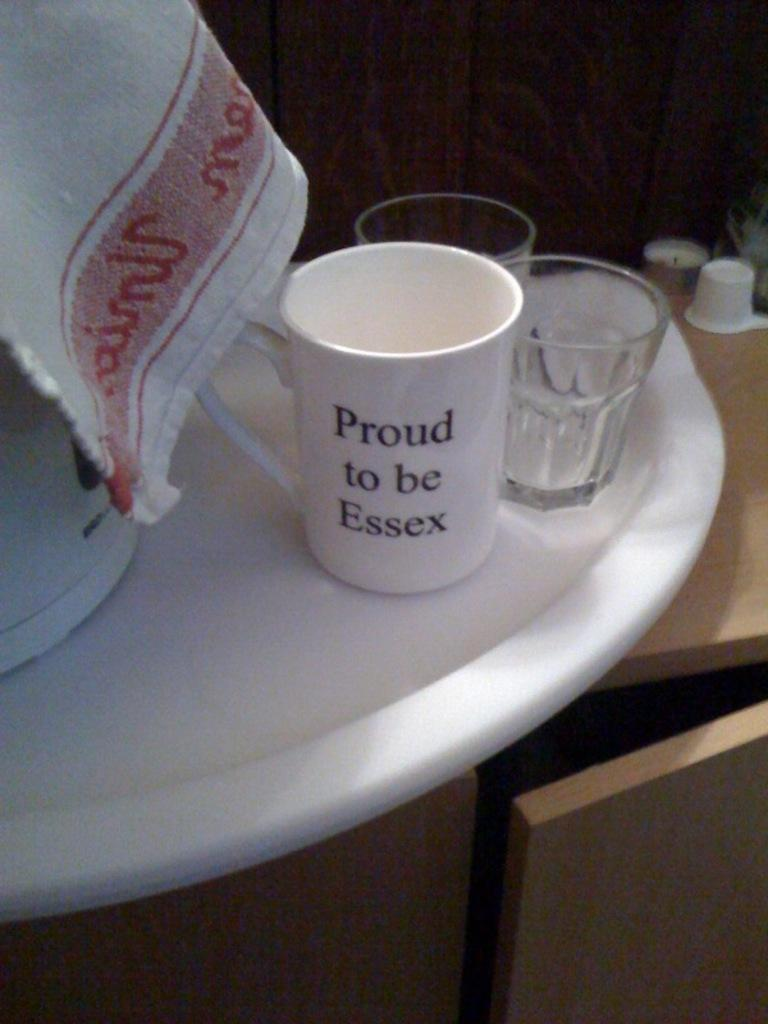What type of furniture is visible in the image? There is a wooden cupboard in the image. What can be seen on top of the wooden cupboard? There are objects on the wooden cupboard. What type of grass is growing in the yard in the image? There is no yard or grass present in the image; it only features a wooden cupboard with objects on it. 